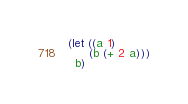Convert code to text. <code><loc_0><loc_0><loc_500><loc_500><_Scheme_>(let ((a 1)
      (b (+ 2 a)))
  b)
</code> 